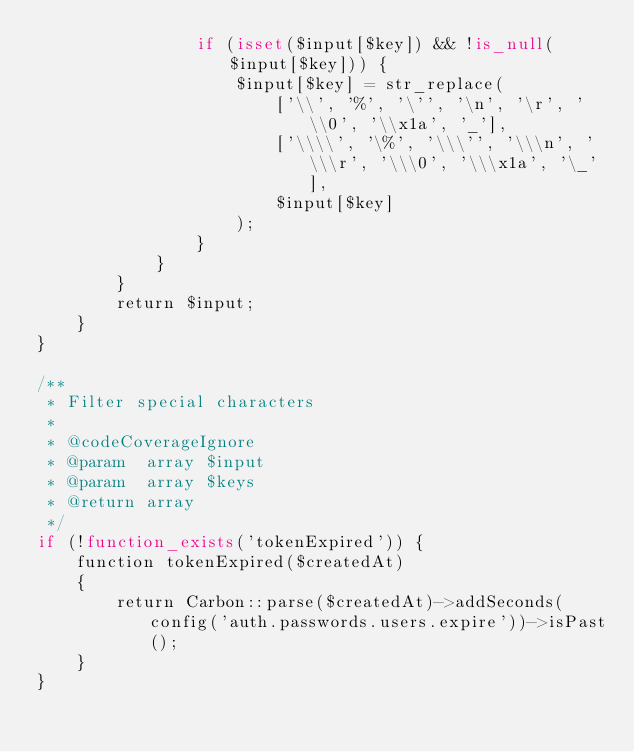<code> <loc_0><loc_0><loc_500><loc_500><_PHP_>                if (isset($input[$key]) && !is_null($input[$key])) {
                    $input[$key] = str_replace(
                        ['\\', '%', '\'', '\n', '\r', '\\0', '\\x1a', '_'],
                        ['\\\\', '\%', '\\\'', '\\\n', '\\\r', '\\\0', '\\\x1a', '\_'],
                        $input[$key]
                    );
                }
            }
        }
        return $input;
    }
}

/**
 * Filter special characters
 *
 * @codeCoverageIgnore
 * @param  array $input
 * @param  array $keys
 * @return array
 */
if (!function_exists('tokenExpired')) {
    function tokenExpired($createdAt)
    {
        return Carbon::parse($createdAt)->addSeconds(config('auth.passwords.users.expire'))->isPast();
    }
}


</code> 